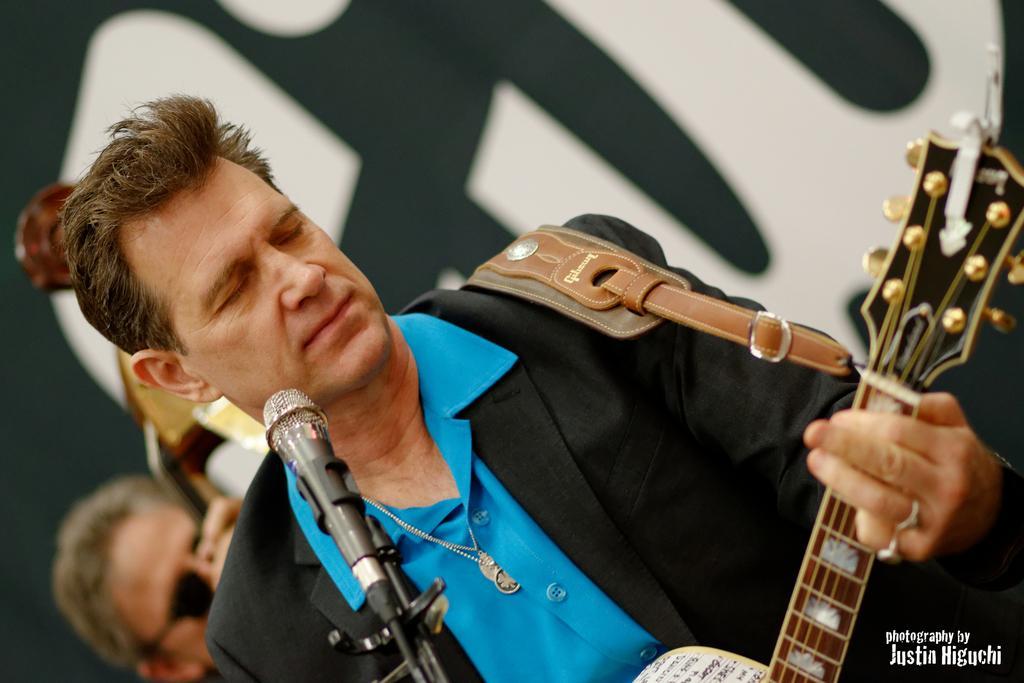In one or two sentences, can you explain what this image depicts? In this image i can see a man wearing a blue shirt and a blazer holding a guitar. I can see a microphone in front of him. In the background i can see another person wearing glasses and a musical instrument and a banner. 